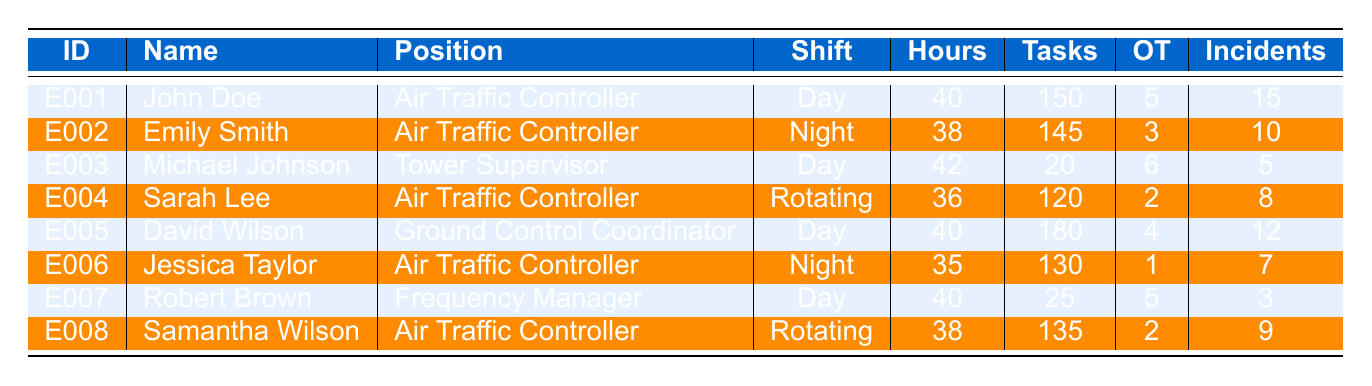What's the total number of overtime hours reported by all employees? To find the total overtime hours, add the overtime hours from each employee: 5 + 3 + 6 + 2 + 4 + 1 + 5 + 2 = 28.
Answer: 28 Which employee handled the most tasks? Looking at the "TasksHandled" column, David Wilson handled the most tasks with a total of 180.
Answer: David Wilson Are there any employees who worked fewer than 36 hours? Reviewing the "WeekHours" column, Michael Johnson worked 42 hours, Sarah Lee worked 36, Jessica Taylor worked 35, and others worked more than 36, indicating that Jessica Taylor is the only employee working fewer than 36 hours.
Answer: Yes How many high traffic incidents did Robert Brown manage? Check Robert Brown's row under "HighTrafficIncidents" where it shows he managed 3 incidents.
Answer: 3 What is the average number of high traffic incidents handled by air traffic controllers? Adding the high traffic incidents for air traffic controllers: 15 (John Doe) + 10 (Emily Smith) + 8 (Sarah Lee) + 9 (Samantha Wilson) = 42. There are 4 air traffic controllers: 42 / 4 = 10.5.
Answer: 10.5 Does any employee have more than 40 hours and handle more than 150 tasks? Checking the table, John Doe has 40 hours and 150 tasks, and David Wilson has 40 hours and 180 tasks. Since neither exceeds 40 hours along with 150 tasks, both qualify.
Answer: Yes Which shift pattern had the most employees working? Upon examining the shift patterns, there are 3 employees on "Day" shift, 2 on "Night," and 2 on "Rotating." Therefore, "Day" shift has the most employees.
Answer: Day If we consider only the rotational shift employees, what is their total number of hours worked? The employees on a rotating shift are Sarah Lee and Samantha Wilson, with 36 and 38 hours respectively; adding those gives 36 + 38 = 74.
Answer: 74 Who has the highest number of high traffic incidents among all employees? Reviewing the "HighTrafficIncidents" column, John Doe leads with 15 incidents, while others have lesser incidents.
Answer: John Doe What is the difference in tasks handled between the employee with the most and the least? The employee with the most tasks handled is David Wilson with 180 tasks, and the least is Michael Johnson with 20 tasks. The difference is 180 - 20 = 160.
Answer: 160 How many employees worked on night shifts and what was the average of their overtime hours? Emily Smith and Jessica Taylor worked night shifts. Their overtime hours are 3 and 1, summing to 4; dividing by 2 gives an average of 2.
Answer: 2 